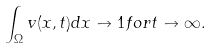Convert formula to latex. <formula><loc_0><loc_0><loc_500><loc_500>\int _ { \Omega } v ( x , t ) d x \to 1 f o r t \to \infty .</formula> 